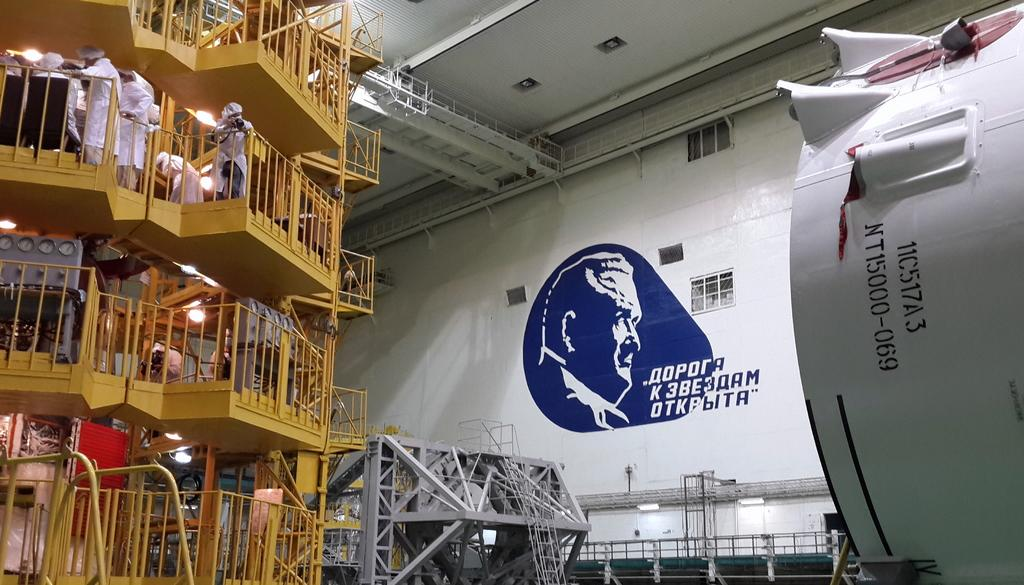What part of a building is shown in the image? The image shows the inner part of a building. Can you describe the people in the image? There are people standing in the image. What safety feature is visible in the image? There are railings visible in the image. What can be seen in the background of the image? There are lights and a white wall in the background of the image. What type of trousers are the people wearing in the image? There is no information about the type of trousers the people are wearing in the image. Can you tell me how much pleasure the people are experiencing in the image? There is no indication of pleasure or any emotional state in the image. 